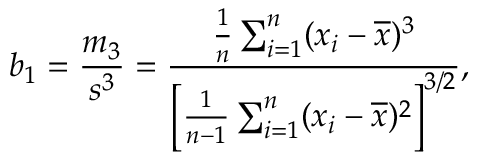Convert formula to latex. <formula><loc_0><loc_0><loc_500><loc_500>b _ { 1 } = { \frac { m _ { 3 } } { s ^ { 3 } } } = { \frac { { \frac { 1 } { n } } \sum _ { i = 1 } ^ { n } ( x _ { i } - { \overline { x } } ) ^ { 3 } } { \left [ { \frac { 1 } { n - 1 } } \sum _ { i = 1 } ^ { n } ( x _ { i } - { \overline { x } } ) ^ { 2 } \right ] ^ { 3 / 2 } } } ,</formula> 